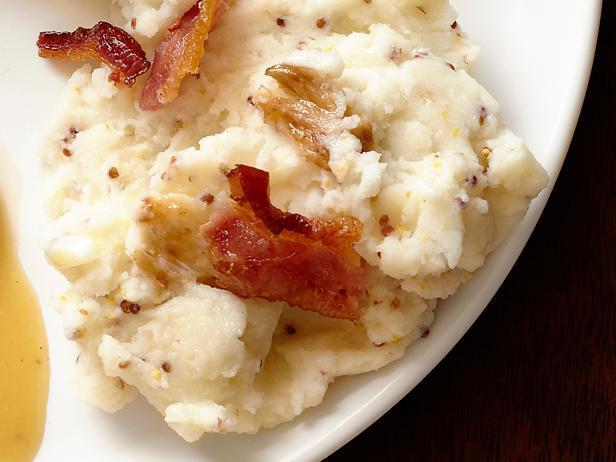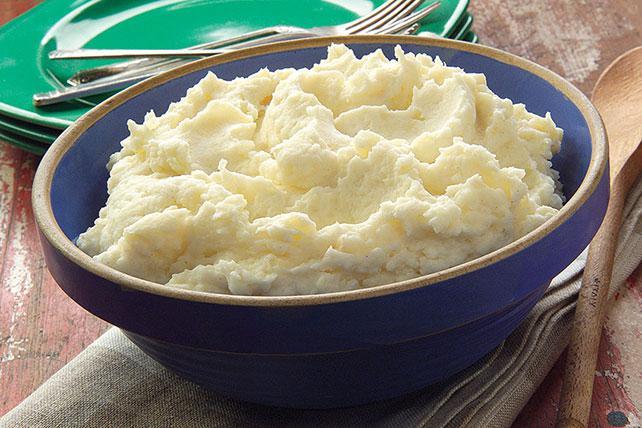The first image is the image on the left, the second image is the image on the right. Examine the images to the left and right. Is the description "The left and right image contains the same of white serving dishes that hold mash potatoes." accurate? Answer yes or no. No. The first image is the image on the left, the second image is the image on the right. Assess this claim about the two images: "Every serving of mashed potatoes has a green herb in it, and one serving appears more buttery or yellow than the other.". Correct or not? Answer yes or no. No. 